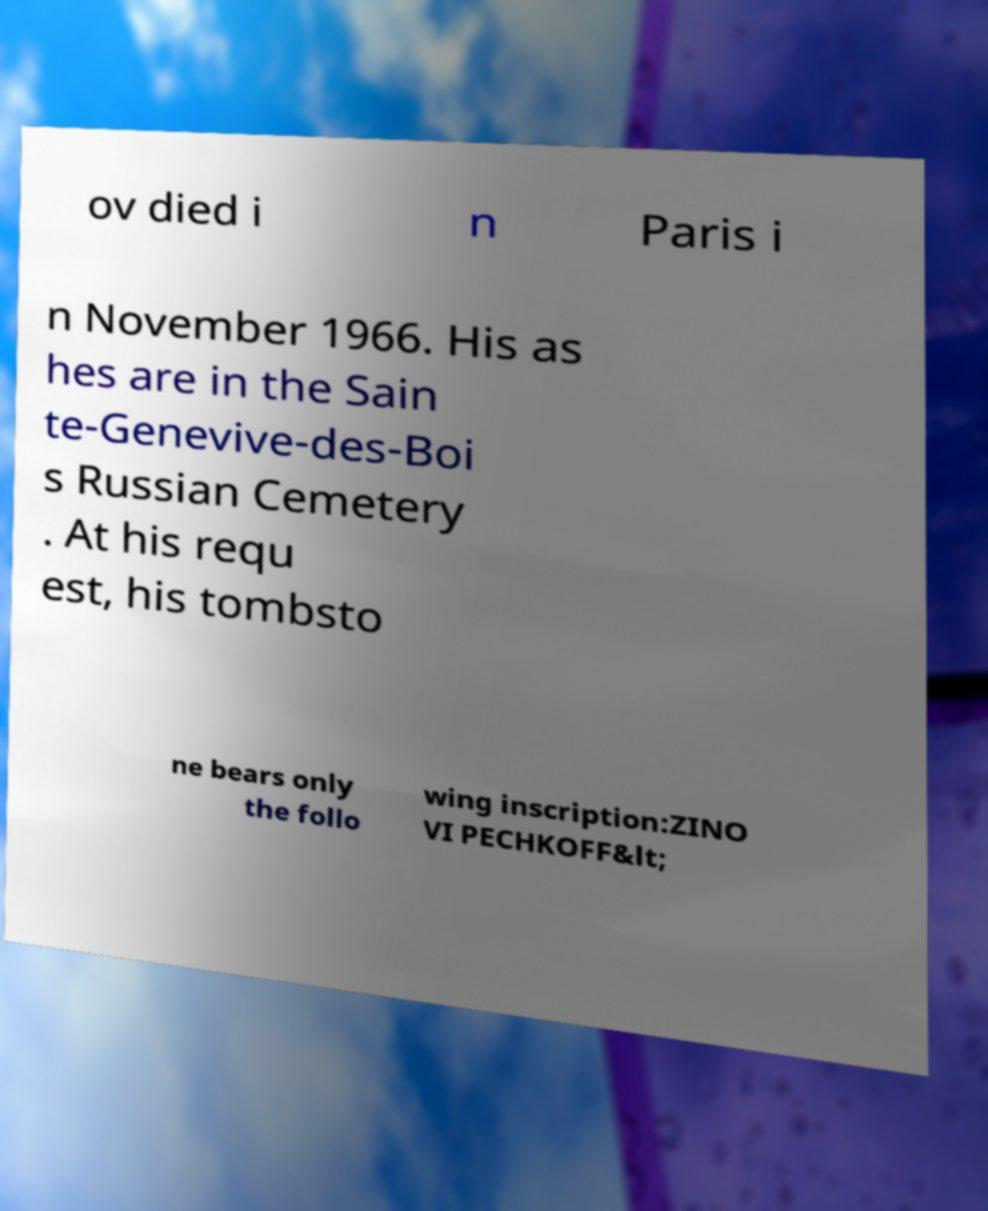Please read and relay the text visible in this image. What does it say? ov died i n Paris i n November 1966. His as hes are in the Sain te-Genevive-des-Boi s Russian Cemetery . At his requ est, his tombsto ne bears only the follo wing inscription:ZINO VI PECHKOFF&lt; 